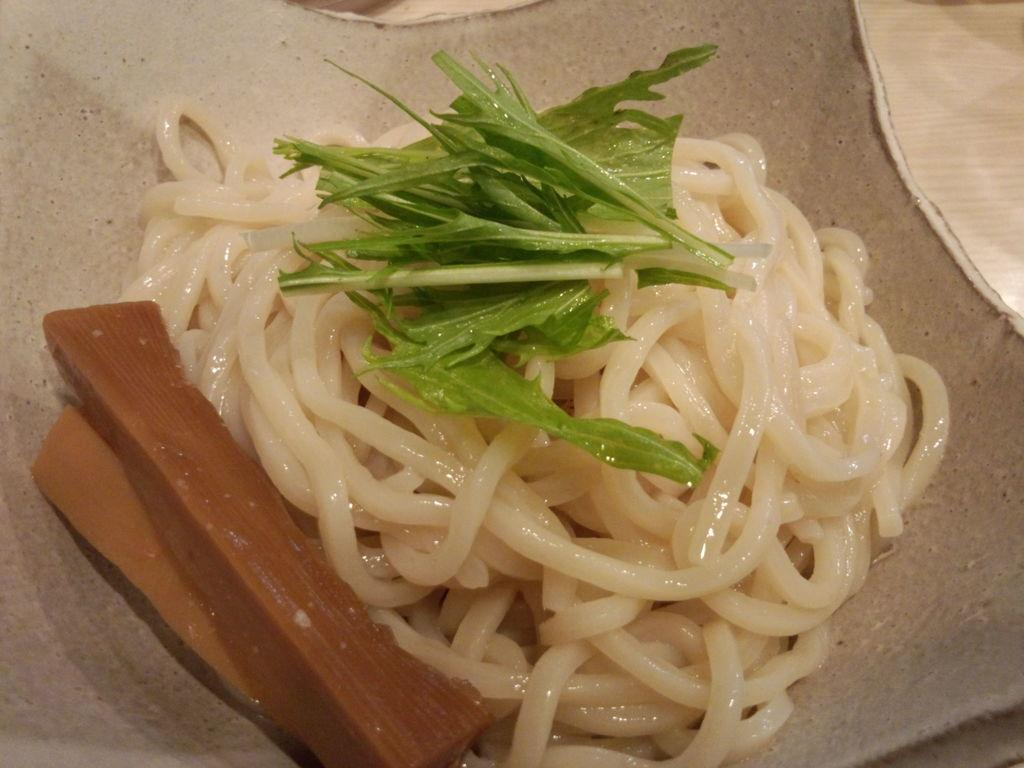What color are the noodles in the image? The noodles in the image are cream-colored. What other food items can be seen in the image? There are food items in green and brown colors in the image. On what object are these food items placed? These food items are on a cream-colored object. Where is the faucet located in the image? There is no faucet present in the image. How do the green and brown food items move around in the image? The green and brown food items do not move around in the image; they are stationary on the cream-colored object. 